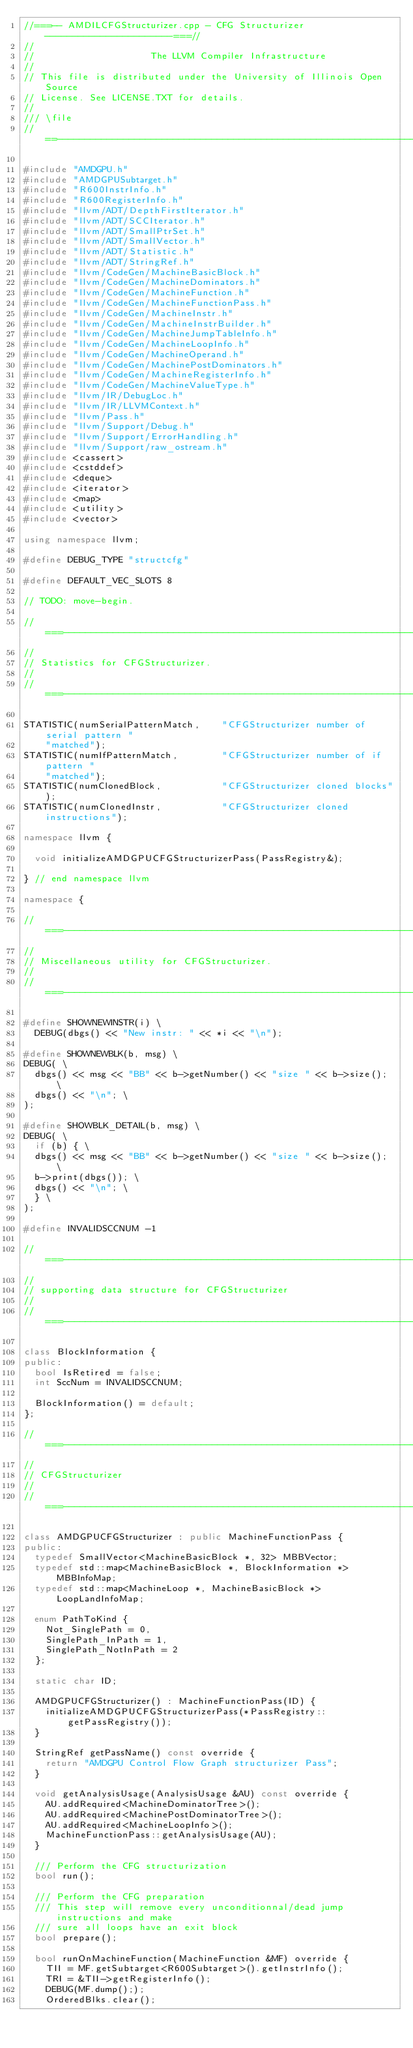Convert code to text. <code><loc_0><loc_0><loc_500><loc_500><_C++_>//===-- AMDILCFGStructurizer.cpp - CFG Structurizer -----------------------===//
//
//                     The LLVM Compiler Infrastructure
//
// This file is distributed under the University of Illinois Open Source
// License. See LICENSE.TXT for details.
//
/// \file
//==-----------------------------------------------------------------------===//

#include "AMDGPU.h"
#include "AMDGPUSubtarget.h"
#include "R600InstrInfo.h"
#include "R600RegisterInfo.h"
#include "llvm/ADT/DepthFirstIterator.h"
#include "llvm/ADT/SCCIterator.h"
#include "llvm/ADT/SmallPtrSet.h"
#include "llvm/ADT/SmallVector.h"
#include "llvm/ADT/Statistic.h"
#include "llvm/ADT/StringRef.h"
#include "llvm/CodeGen/MachineBasicBlock.h"
#include "llvm/CodeGen/MachineDominators.h"
#include "llvm/CodeGen/MachineFunction.h"
#include "llvm/CodeGen/MachineFunctionPass.h"
#include "llvm/CodeGen/MachineInstr.h"
#include "llvm/CodeGen/MachineInstrBuilder.h"
#include "llvm/CodeGen/MachineJumpTableInfo.h"
#include "llvm/CodeGen/MachineLoopInfo.h"
#include "llvm/CodeGen/MachineOperand.h"
#include "llvm/CodeGen/MachinePostDominators.h"
#include "llvm/CodeGen/MachineRegisterInfo.h"
#include "llvm/CodeGen/MachineValueType.h"
#include "llvm/IR/DebugLoc.h"
#include "llvm/IR/LLVMContext.h"
#include "llvm/Pass.h"
#include "llvm/Support/Debug.h"
#include "llvm/Support/ErrorHandling.h"
#include "llvm/Support/raw_ostream.h"
#include <cassert>
#include <cstddef>
#include <deque>
#include <iterator>
#include <map>
#include <utility>
#include <vector>

using namespace llvm;

#define DEBUG_TYPE "structcfg"

#define DEFAULT_VEC_SLOTS 8

// TODO: move-begin.

//===----------------------------------------------------------------------===//
//
// Statistics for CFGStructurizer.
//
//===----------------------------------------------------------------------===//

STATISTIC(numSerialPatternMatch,    "CFGStructurizer number of serial pattern "
    "matched");
STATISTIC(numIfPatternMatch,        "CFGStructurizer number of if pattern "
    "matched");
STATISTIC(numClonedBlock,           "CFGStructurizer cloned blocks");
STATISTIC(numClonedInstr,           "CFGStructurizer cloned instructions");

namespace llvm {

  void initializeAMDGPUCFGStructurizerPass(PassRegistry&);

} // end namespace llvm

namespace {

//===----------------------------------------------------------------------===//
//
// Miscellaneous utility for CFGStructurizer.
//
//===----------------------------------------------------------------------===//

#define SHOWNEWINSTR(i) \
  DEBUG(dbgs() << "New instr: " << *i << "\n");

#define SHOWNEWBLK(b, msg) \
DEBUG( \
  dbgs() << msg << "BB" << b->getNumber() << "size " << b->size(); \
  dbgs() << "\n"; \
);

#define SHOWBLK_DETAIL(b, msg) \
DEBUG( \
  if (b) { \
  dbgs() << msg << "BB" << b->getNumber() << "size " << b->size(); \
  b->print(dbgs()); \
  dbgs() << "\n"; \
  } \
);

#define INVALIDSCCNUM -1

//===----------------------------------------------------------------------===//
//
// supporting data structure for CFGStructurizer
//
//===----------------------------------------------------------------------===//

class BlockInformation {
public:
  bool IsRetired = false;
  int SccNum = INVALIDSCCNUM;

  BlockInformation() = default;
};

//===----------------------------------------------------------------------===//
//
// CFGStructurizer
//
//===----------------------------------------------------------------------===//

class AMDGPUCFGStructurizer : public MachineFunctionPass {
public:
  typedef SmallVector<MachineBasicBlock *, 32> MBBVector;
  typedef std::map<MachineBasicBlock *, BlockInformation *> MBBInfoMap;
  typedef std::map<MachineLoop *, MachineBasicBlock *> LoopLandInfoMap;

  enum PathToKind {
    Not_SinglePath = 0,
    SinglePath_InPath = 1,
    SinglePath_NotInPath = 2
  };

  static char ID;

  AMDGPUCFGStructurizer() : MachineFunctionPass(ID) {
    initializeAMDGPUCFGStructurizerPass(*PassRegistry::getPassRegistry());
  }

  StringRef getPassName() const override {
    return "AMDGPU Control Flow Graph structurizer Pass";
  }

  void getAnalysisUsage(AnalysisUsage &AU) const override {
    AU.addRequired<MachineDominatorTree>();
    AU.addRequired<MachinePostDominatorTree>();
    AU.addRequired<MachineLoopInfo>();
    MachineFunctionPass::getAnalysisUsage(AU);
  }

  /// Perform the CFG structurization
  bool run();

  /// Perform the CFG preparation
  /// This step will remove every unconditionnal/dead jump instructions and make
  /// sure all loops have an exit block
  bool prepare();

  bool runOnMachineFunction(MachineFunction &MF) override {
    TII = MF.getSubtarget<R600Subtarget>().getInstrInfo();
    TRI = &TII->getRegisterInfo();
    DEBUG(MF.dump(););
    OrderedBlks.clear();</code> 